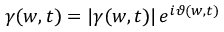Convert formula to latex. <formula><loc_0><loc_0><loc_500><loc_500>\gamma ( w , t ) = | \gamma ( w , t ) | \, e ^ { i \vartheta ( w , t ) }</formula> 